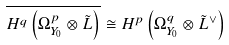Convert formula to latex. <formula><loc_0><loc_0><loc_500><loc_500>\overline { H ^ { q } \left ( \Omega _ { Y _ { 0 } } ^ { p } \otimes \tilde { L } \right ) } \cong H ^ { p } \left ( \Omega _ { Y _ { 0 } } ^ { q } \otimes \tilde { L } ^ { \vee } \right )</formula> 